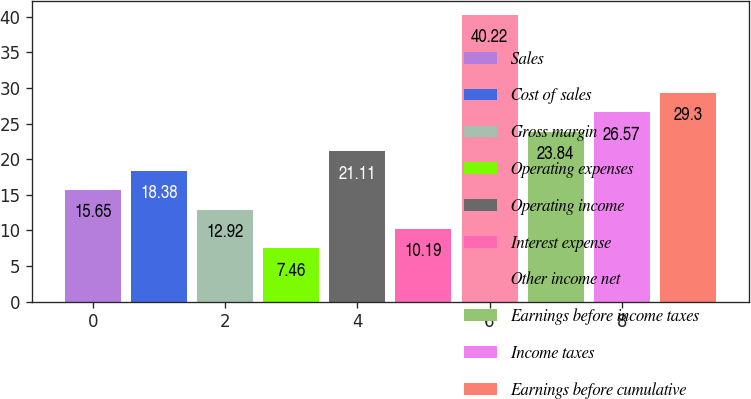Convert chart to OTSL. <chart><loc_0><loc_0><loc_500><loc_500><bar_chart><fcel>Sales<fcel>Cost of sales<fcel>Gross margin<fcel>Operating expenses<fcel>Operating income<fcel>Interest expense<fcel>Other income net<fcel>Earnings before income taxes<fcel>Income taxes<fcel>Earnings before cumulative<nl><fcel>15.65<fcel>18.38<fcel>12.92<fcel>7.46<fcel>21.11<fcel>10.19<fcel>40.22<fcel>23.84<fcel>26.57<fcel>29.3<nl></chart> 